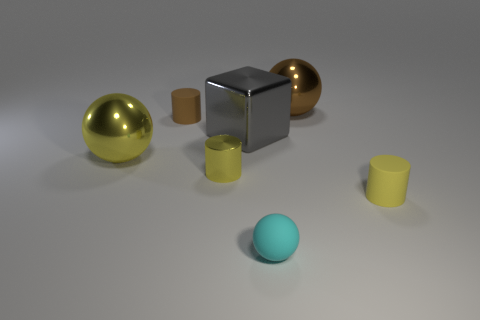Add 2 big red metal cubes. How many objects exist? 9 Subtract all cylinders. How many objects are left? 4 Add 5 spheres. How many spheres are left? 8 Add 3 brown balls. How many brown balls exist? 4 Subtract 0 purple cubes. How many objects are left? 7 Subtract all tiny rubber cylinders. Subtract all small yellow metal things. How many objects are left? 4 